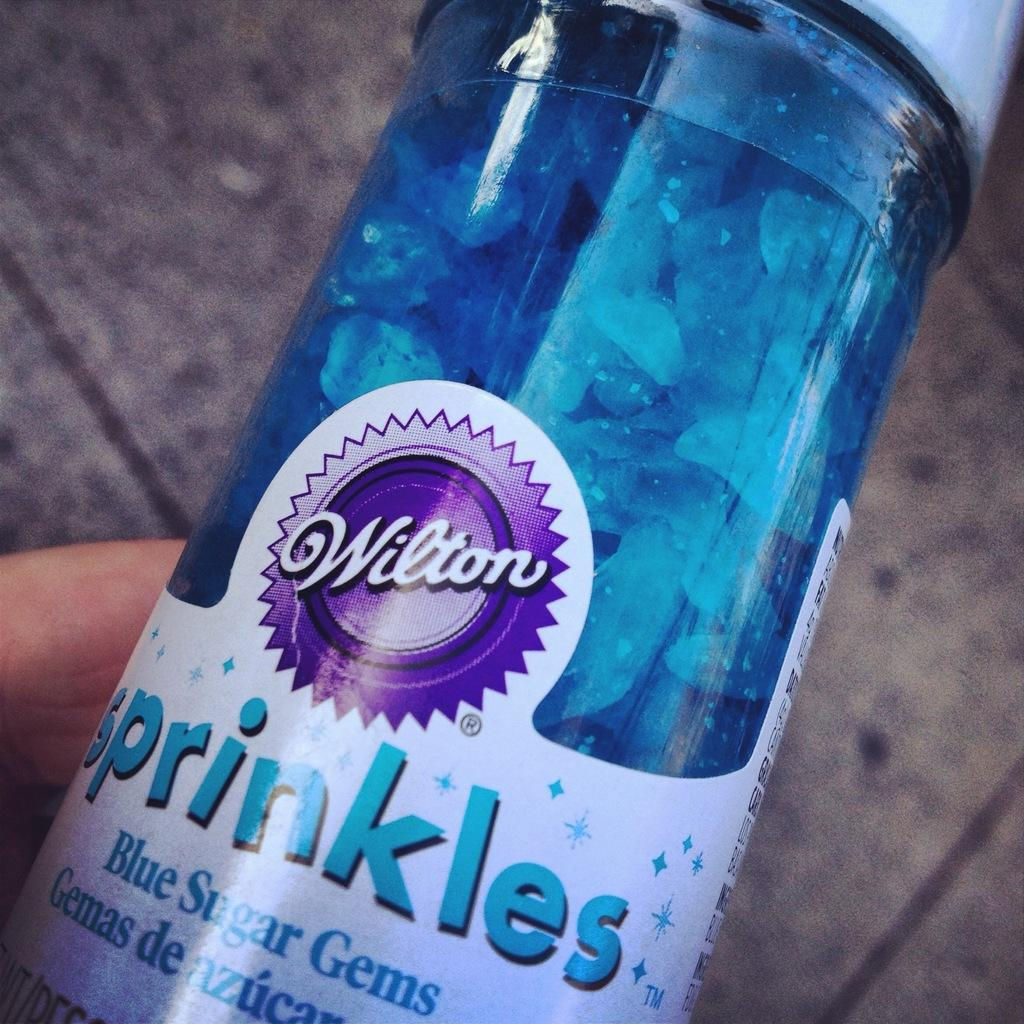What is the color of the bottle in the image? The bottle in the image is blue. What is written on the bottle? The bottle is labelled as "sprinkles". What can be found inside the bottle? There are gems inside the bottle. What type of vein can be seen running through the gems in the image? There is no vein present in the image; it features a blue color bottle with gems inside. 